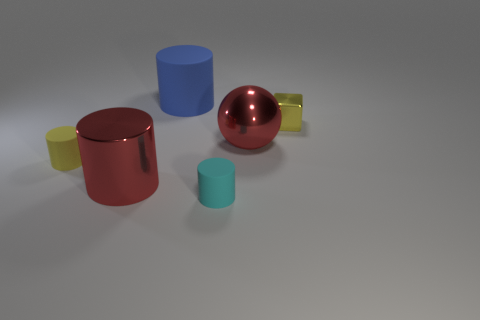Add 4 small shiny blocks. How many objects exist? 10 Subtract all cubes. How many objects are left? 5 Add 2 gray blocks. How many gray blocks exist? 2 Subtract 0 purple cylinders. How many objects are left? 6 Subtract all tiny green rubber spheres. Subtract all big cylinders. How many objects are left? 4 Add 4 big objects. How many big objects are left? 7 